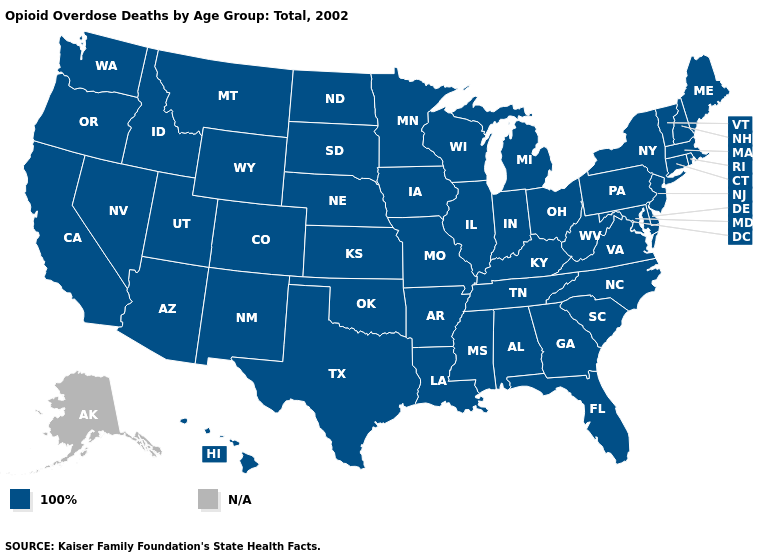How many symbols are there in the legend?
Quick response, please. 2. Name the states that have a value in the range 100%?
Give a very brief answer. Alabama, Arizona, Arkansas, California, Colorado, Connecticut, Delaware, Florida, Georgia, Hawaii, Idaho, Illinois, Indiana, Iowa, Kansas, Kentucky, Louisiana, Maine, Maryland, Massachusetts, Michigan, Minnesota, Mississippi, Missouri, Montana, Nebraska, Nevada, New Hampshire, New Jersey, New Mexico, New York, North Carolina, North Dakota, Ohio, Oklahoma, Oregon, Pennsylvania, Rhode Island, South Carolina, South Dakota, Tennessee, Texas, Utah, Vermont, Virginia, Washington, West Virginia, Wisconsin, Wyoming. Does the first symbol in the legend represent the smallest category?
Short answer required. Yes. Name the states that have a value in the range 100%?
Quick response, please. Alabama, Arizona, Arkansas, California, Colorado, Connecticut, Delaware, Florida, Georgia, Hawaii, Idaho, Illinois, Indiana, Iowa, Kansas, Kentucky, Louisiana, Maine, Maryland, Massachusetts, Michigan, Minnesota, Mississippi, Missouri, Montana, Nebraska, Nevada, New Hampshire, New Jersey, New Mexico, New York, North Carolina, North Dakota, Ohio, Oklahoma, Oregon, Pennsylvania, Rhode Island, South Carolina, South Dakota, Tennessee, Texas, Utah, Vermont, Virginia, Washington, West Virginia, Wisconsin, Wyoming. What is the highest value in the USA?
Keep it brief. 100%. What is the value of Wyoming?
Concise answer only. 100%. Name the states that have a value in the range 100%?
Concise answer only. Alabama, Arizona, Arkansas, California, Colorado, Connecticut, Delaware, Florida, Georgia, Hawaii, Idaho, Illinois, Indiana, Iowa, Kansas, Kentucky, Louisiana, Maine, Maryland, Massachusetts, Michigan, Minnesota, Mississippi, Missouri, Montana, Nebraska, Nevada, New Hampshire, New Jersey, New Mexico, New York, North Carolina, North Dakota, Ohio, Oklahoma, Oregon, Pennsylvania, Rhode Island, South Carolina, South Dakota, Tennessee, Texas, Utah, Vermont, Virginia, Washington, West Virginia, Wisconsin, Wyoming. Which states hav the highest value in the South?
Short answer required. Alabama, Arkansas, Delaware, Florida, Georgia, Kentucky, Louisiana, Maryland, Mississippi, North Carolina, Oklahoma, South Carolina, Tennessee, Texas, Virginia, West Virginia. Is the legend a continuous bar?
Short answer required. No. Is the legend a continuous bar?
Keep it brief. No. Which states have the lowest value in the MidWest?
Write a very short answer. Illinois, Indiana, Iowa, Kansas, Michigan, Minnesota, Missouri, Nebraska, North Dakota, Ohio, South Dakota, Wisconsin. Name the states that have a value in the range N/A?
Give a very brief answer. Alaska. What is the value of Wyoming?
Concise answer only. 100%. 